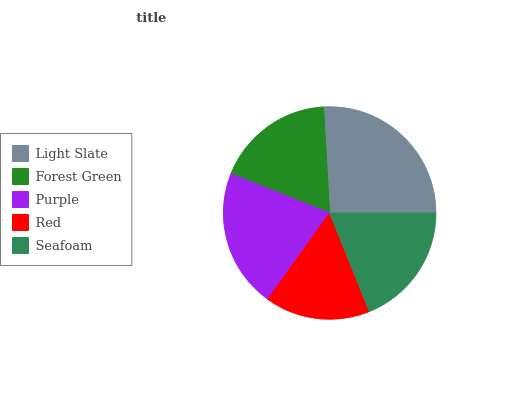Is Red the minimum?
Answer yes or no. Yes. Is Light Slate the maximum?
Answer yes or no. Yes. Is Forest Green the minimum?
Answer yes or no. No. Is Forest Green the maximum?
Answer yes or no. No. Is Light Slate greater than Forest Green?
Answer yes or no. Yes. Is Forest Green less than Light Slate?
Answer yes or no. Yes. Is Forest Green greater than Light Slate?
Answer yes or no. No. Is Light Slate less than Forest Green?
Answer yes or no. No. Is Seafoam the high median?
Answer yes or no. Yes. Is Seafoam the low median?
Answer yes or no. Yes. Is Purple the high median?
Answer yes or no. No. Is Light Slate the low median?
Answer yes or no. No. 